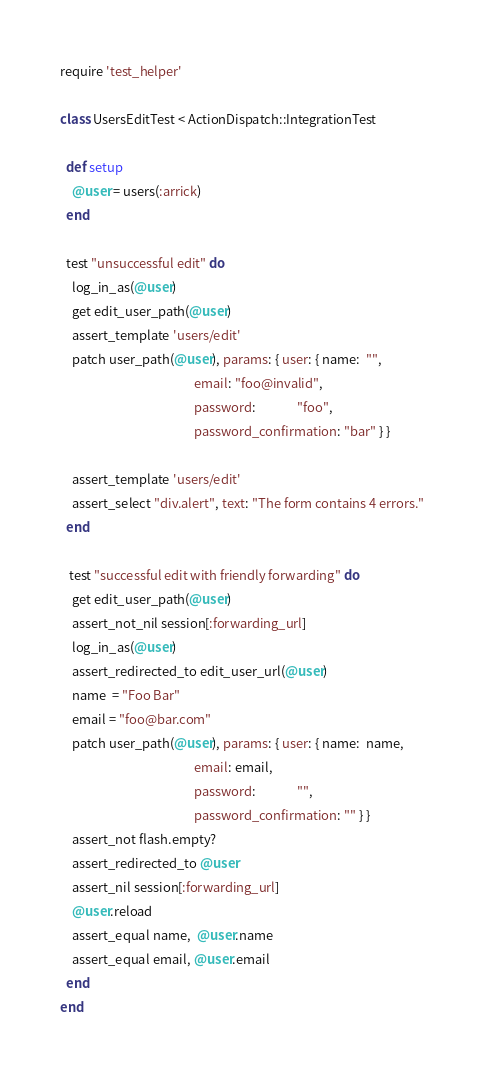<code> <loc_0><loc_0><loc_500><loc_500><_Ruby_>require 'test_helper'

class UsersEditTest < ActionDispatch::IntegrationTest

  def setup
    @user = users(:arrick)
  end

  test "unsuccessful edit" do
    log_in_as(@user)
    get edit_user_path(@user)
    assert_template 'users/edit'
    patch user_path(@user), params: { user: { name:  "",
                                              email: "foo@invalid",
                                              password:              "foo",
                                              password_confirmation: "bar" } }

    assert_template 'users/edit'
    assert_select "div.alert", text: "The form contains 4 errors."
  end
  
   test "successful edit with friendly forwarding" do
    get edit_user_path(@user)
    assert_not_nil session[:forwarding_url]
    log_in_as(@user)
    assert_redirected_to edit_user_url(@user)
    name  = "Foo Bar"
    email = "foo@bar.com"
    patch user_path(@user), params: { user: { name:  name,
                                              email: email,
                                              password:              "",
                                              password_confirmation: "" } }
    assert_not flash.empty?
    assert_redirected_to @user
    assert_nil session[:forwarding_url]
    @user.reload
    assert_equal name,  @user.name
    assert_equal email, @user.email
  end
end</code> 